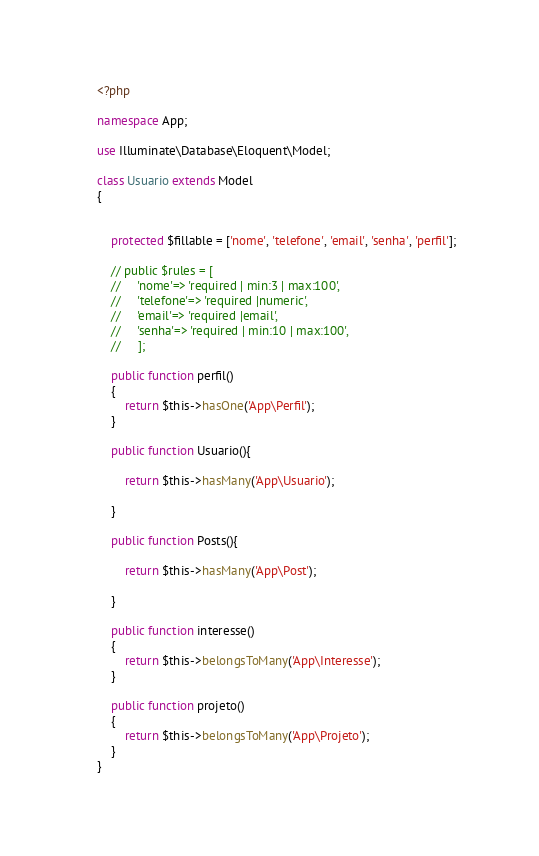Convert code to text. <code><loc_0><loc_0><loc_500><loc_500><_PHP_><?php

namespace App;

use Illuminate\Database\Eloquent\Model;

class Usuario extends Model
{
    
    
    protected $fillable = ['nome', 'telefone', 'email', 'senha', 'perfil'];

    // public $rules = [
    //     'nome'=> 'required | min:3 | max:100',
    //     'telefone'=> 'required |numeric',
    //     'email'=> 'required |email',
    //     'senha'=> 'required | min:10 | max:100',
    //     ];
    
    public function perfil()
    {
        return $this->hasOne('App\Perfil');
    }
    
    public function Usuario(){
        
        return $this->hasMany('App\Usuario');

    }
    
    public function Posts(){
        
        return $this->hasMany('App\Post');

    }

    public function interesse()
    {
        return $this->belongsToMany('App\Interesse');
    }

    public function projeto()
    {
        return $this->belongsToMany('App\Projeto');
    }
}

</code> 